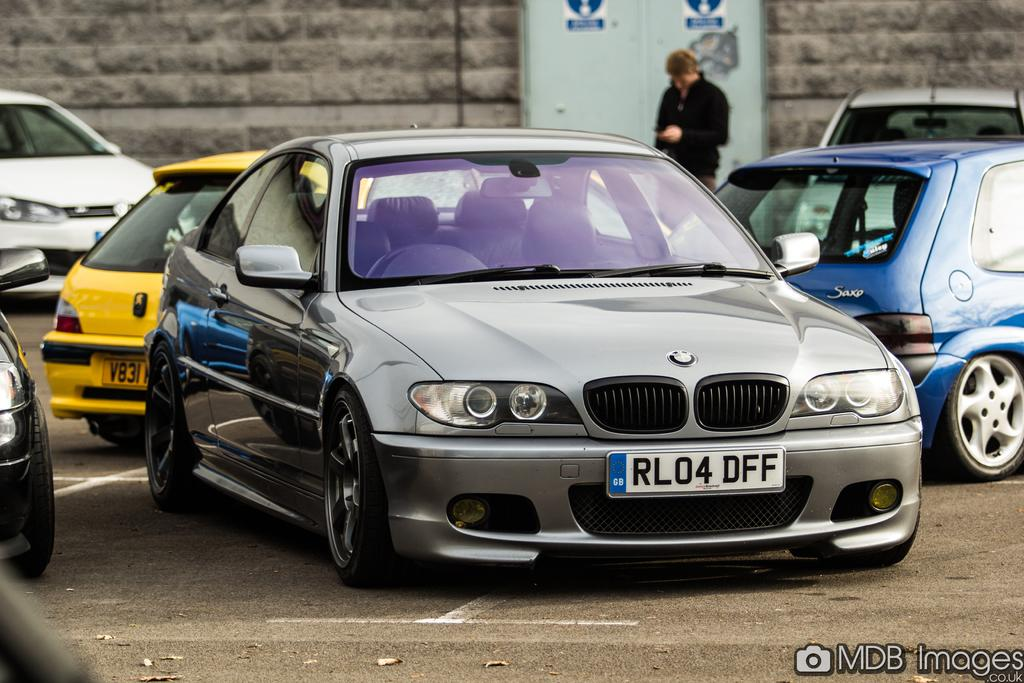<image>
Relay a brief, clear account of the picture shown. The license plate info on the sports car is RL04DFF 